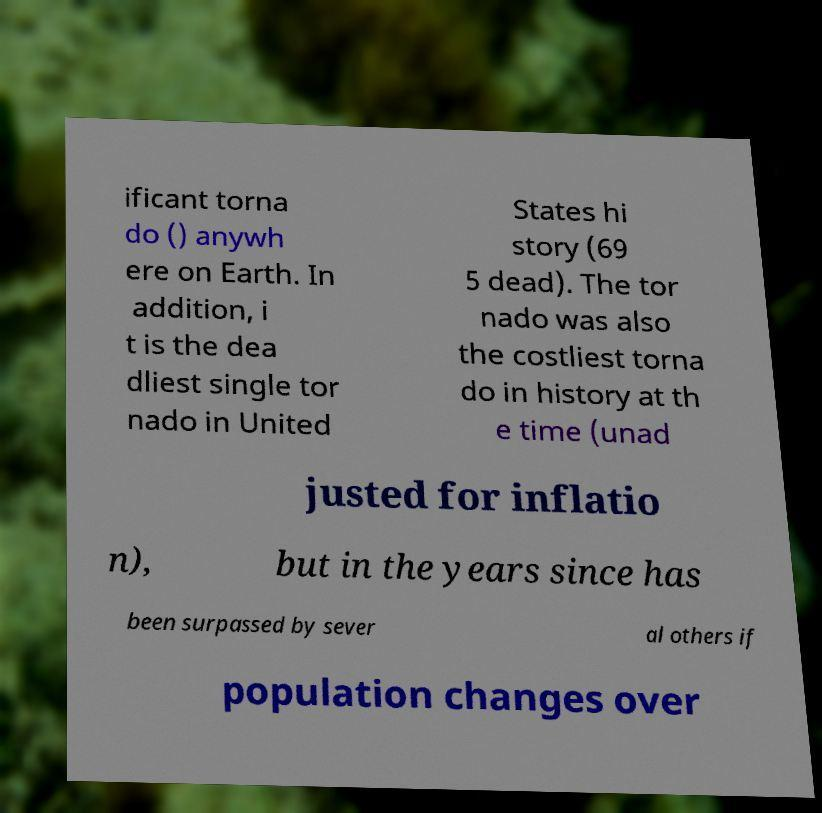Please identify and transcribe the text found in this image. ificant torna do () anywh ere on Earth. In addition, i t is the dea dliest single tor nado in United States hi story (69 5 dead). The tor nado was also the costliest torna do in history at th e time (unad justed for inflatio n), but in the years since has been surpassed by sever al others if population changes over 